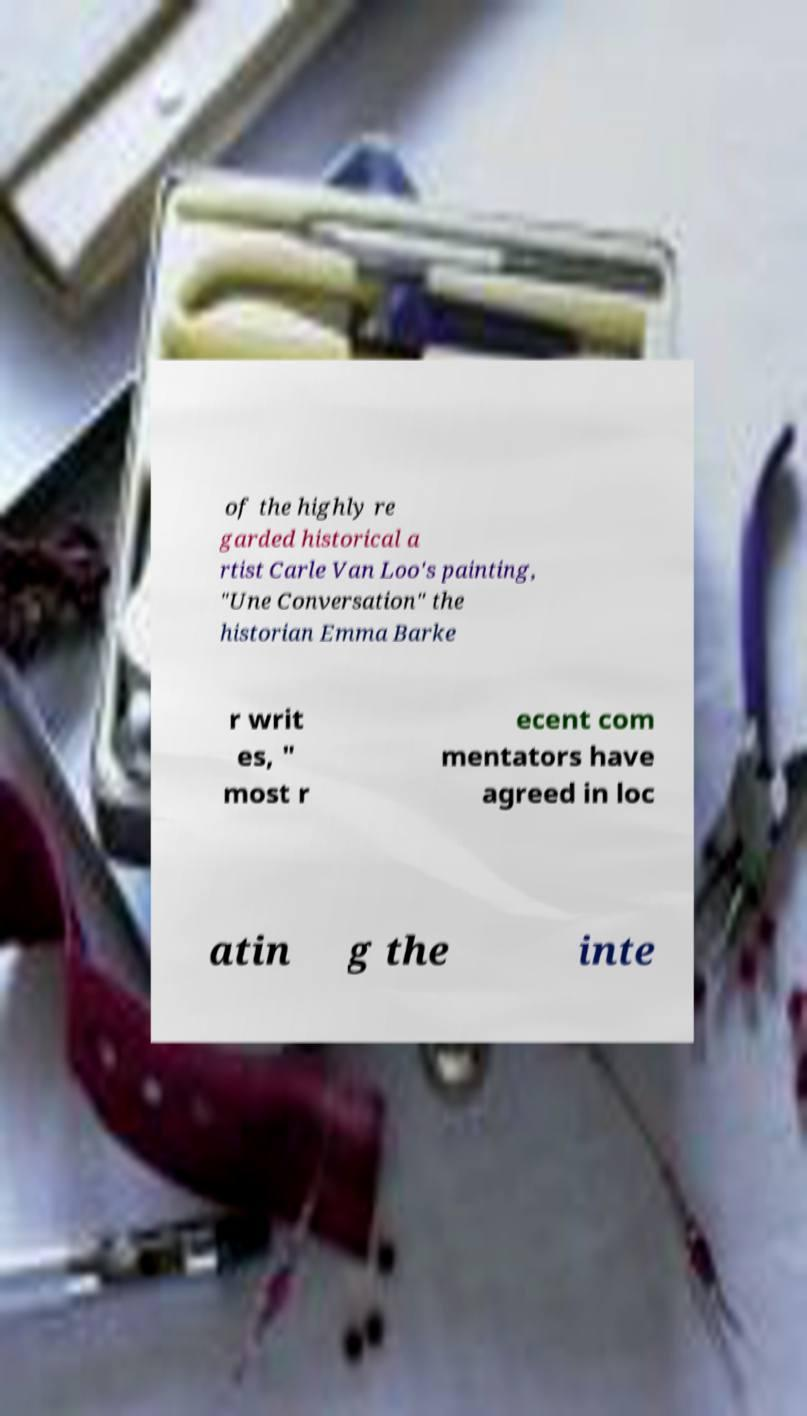Could you assist in decoding the text presented in this image and type it out clearly? of the highly re garded historical a rtist Carle Van Loo's painting, "Une Conversation" the historian Emma Barke r writ es, " most r ecent com mentators have agreed in loc atin g the inte 